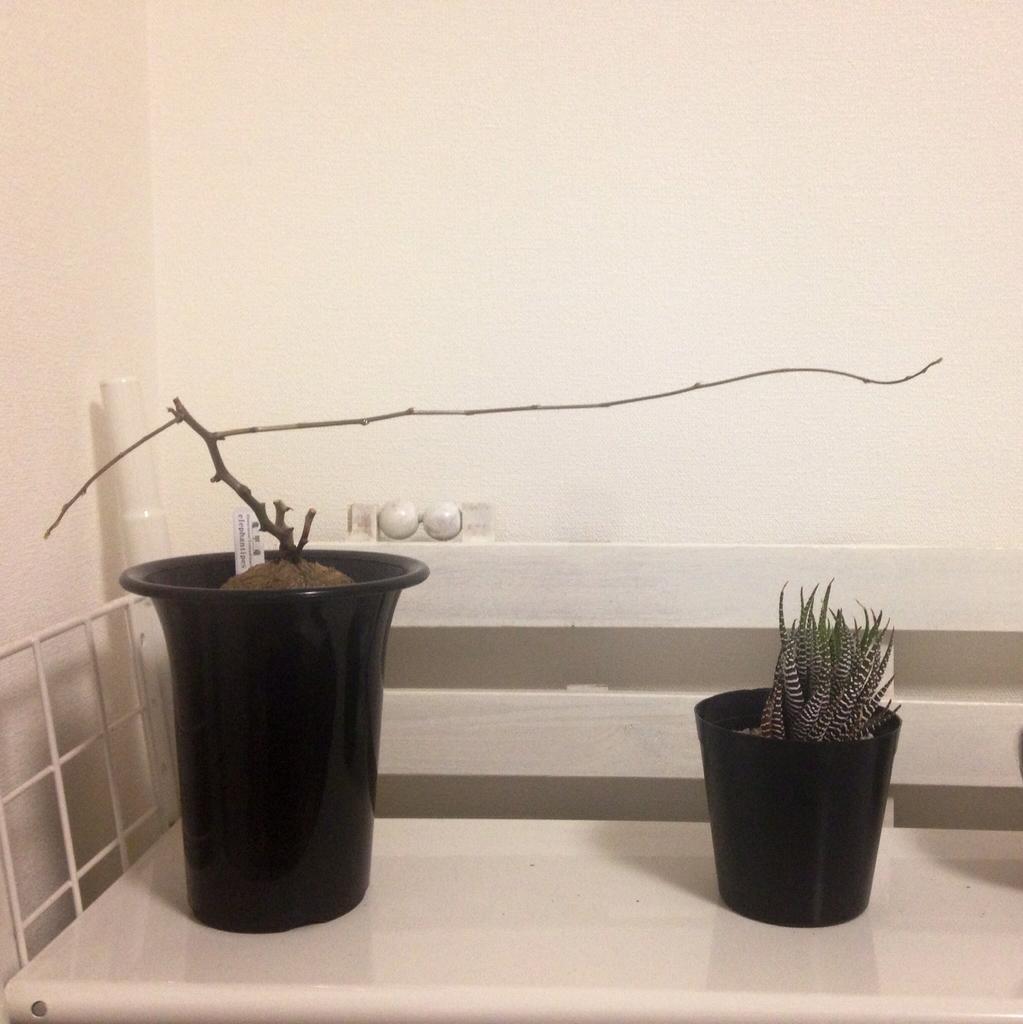Please provide a concise description of this image. In this image we can see the houseplants on a white surface. Behind them, we can see the wall. On the left side, we can see the metal grill. 